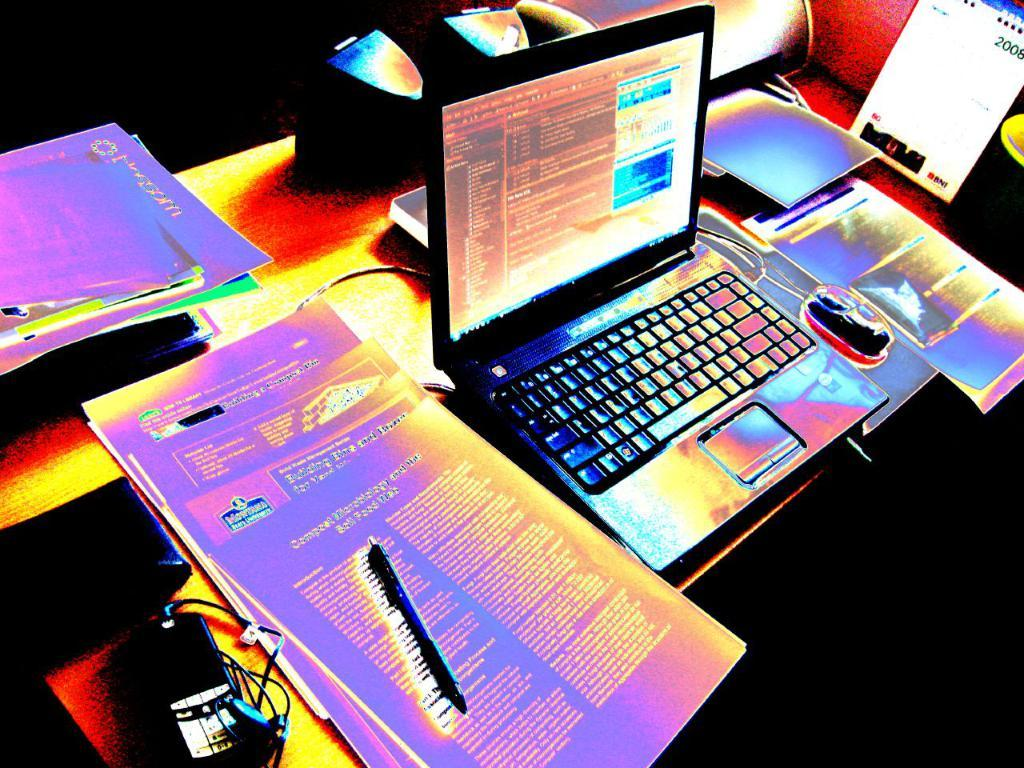<image>
Provide a brief description of the given image. A computer desk with a laptop on it and a book on to the right with the date 2008 on it. 